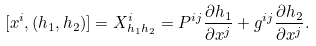<formula> <loc_0><loc_0><loc_500><loc_500>[ x ^ { i } , ( h _ { 1 } , h _ { 2 } ) ] = X _ { h _ { 1 } h _ { 2 } } ^ { i } = P ^ { i j } \frac { \partial h _ { 1 } } { \partial x ^ { j } } + g ^ { i j } \frac { \partial h _ { 2 } } { \partial x ^ { j } } .</formula> 